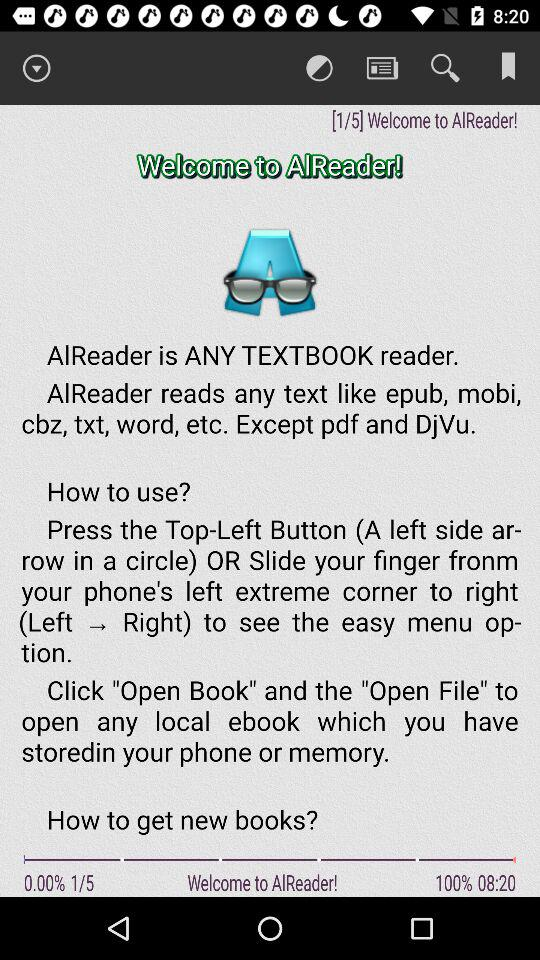What is the count of pages? The count of pages is 5. 